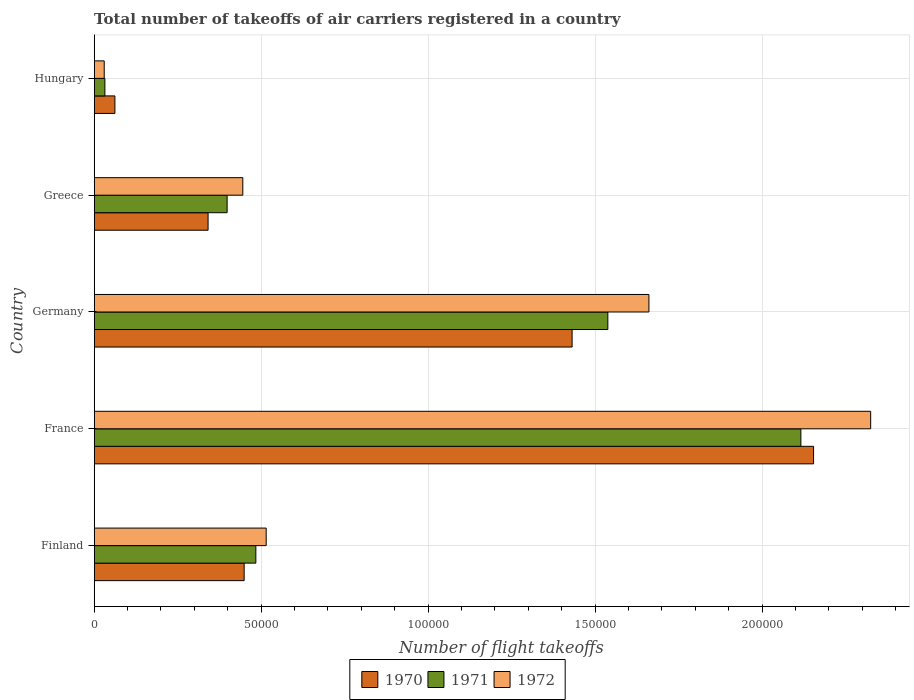How many groups of bars are there?
Keep it short and to the point. 5. Are the number of bars per tick equal to the number of legend labels?
Provide a succinct answer. Yes. How many bars are there on the 1st tick from the bottom?
Provide a succinct answer. 3. What is the label of the 4th group of bars from the top?
Offer a terse response. France. What is the total number of flight takeoffs in 1972 in Hungary?
Make the answer very short. 3000. Across all countries, what is the maximum total number of flight takeoffs in 1971?
Your answer should be very brief. 2.12e+05. Across all countries, what is the minimum total number of flight takeoffs in 1970?
Offer a terse response. 6200. In which country was the total number of flight takeoffs in 1970 maximum?
Give a very brief answer. France. In which country was the total number of flight takeoffs in 1970 minimum?
Your response must be concise. Hungary. What is the total total number of flight takeoffs in 1971 in the graph?
Make the answer very short. 4.57e+05. What is the difference between the total number of flight takeoffs in 1971 in Germany and that in Hungary?
Provide a succinct answer. 1.51e+05. What is the difference between the total number of flight takeoffs in 1972 in France and the total number of flight takeoffs in 1970 in Hungary?
Offer a terse response. 2.26e+05. What is the average total number of flight takeoffs in 1971 per country?
Ensure brevity in your answer.  9.14e+04. What is the difference between the total number of flight takeoffs in 1972 and total number of flight takeoffs in 1970 in Finland?
Ensure brevity in your answer.  6600. In how many countries, is the total number of flight takeoffs in 1972 greater than 60000 ?
Offer a very short reply. 2. What is the ratio of the total number of flight takeoffs in 1971 in France to that in Hungary?
Your answer should be very brief. 66.12. Is the difference between the total number of flight takeoffs in 1972 in Germany and Hungary greater than the difference between the total number of flight takeoffs in 1970 in Germany and Hungary?
Your answer should be very brief. Yes. What is the difference between the highest and the second highest total number of flight takeoffs in 1972?
Keep it short and to the point. 6.64e+04. What is the difference between the highest and the lowest total number of flight takeoffs in 1970?
Offer a very short reply. 2.09e+05. What does the 3rd bar from the top in Greece represents?
Make the answer very short. 1970. How many bars are there?
Make the answer very short. 15. Are all the bars in the graph horizontal?
Offer a terse response. Yes. What is the difference between two consecutive major ticks on the X-axis?
Make the answer very short. 5.00e+04. Does the graph contain any zero values?
Provide a succinct answer. No. Where does the legend appear in the graph?
Offer a terse response. Bottom center. How many legend labels are there?
Provide a succinct answer. 3. How are the legend labels stacked?
Your answer should be very brief. Horizontal. What is the title of the graph?
Provide a succinct answer. Total number of takeoffs of air carriers registered in a country. Does "2009" appear as one of the legend labels in the graph?
Your answer should be compact. No. What is the label or title of the X-axis?
Provide a short and direct response. Number of flight takeoffs. What is the Number of flight takeoffs in 1970 in Finland?
Your answer should be compact. 4.49e+04. What is the Number of flight takeoffs of 1971 in Finland?
Your answer should be very brief. 4.84e+04. What is the Number of flight takeoffs in 1972 in Finland?
Offer a very short reply. 5.15e+04. What is the Number of flight takeoffs of 1970 in France?
Offer a very short reply. 2.15e+05. What is the Number of flight takeoffs of 1971 in France?
Provide a short and direct response. 2.12e+05. What is the Number of flight takeoffs in 1972 in France?
Provide a succinct answer. 2.32e+05. What is the Number of flight takeoffs of 1970 in Germany?
Provide a succinct answer. 1.43e+05. What is the Number of flight takeoffs in 1971 in Germany?
Your answer should be very brief. 1.54e+05. What is the Number of flight takeoffs in 1972 in Germany?
Offer a very short reply. 1.66e+05. What is the Number of flight takeoffs of 1970 in Greece?
Keep it short and to the point. 3.41e+04. What is the Number of flight takeoffs of 1971 in Greece?
Give a very brief answer. 3.98e+04. What is the Number of flight takeoffs of 1972 in Greece?
Make the answer very short. 4.45e+04. What is the Number of flight takeoffs of 1970 in Hungary?
Ensure brevity in your answer.  6200. What is the Number of flight takeoffs in 1971 in Hungary?
Provide a succinct answer. 3200. What is the Number of flight takeoffs in 1972 in Hungary?
Provide a short and direct response. 3000. Across all countries, what is the maximum Number of flight takeoffs in 1970?
Give a very brief answer. 2.15e+05. Across all countries, what is the maximum Number of flight takeoffs in 1971?
Provide a succinct answer. 2.12e+05. Across all countries, what is the maximum Number of flight takeoffs of 1972?
Provide a short and direct response. 2.32e+05. Across all countries, what is the minimum Number of flight takeoffs of 1970?
Make the answer very short. 6200. Across all countries, what is the minimum Number of flight takeoffs of 1971?
Offer a terse response. 3200. Across all countries, what is the minimum Number of flight takeoffs in 1972?
Offer a terse response. 3000. What is the total Number of flight takeoffs of 1970 in the graph?
Make the answer very short. 4.44e+05. What is the total Number of flight takeoffs in 1971 in the graph?
Your answer should be very brief. 4.57e+05. What is the total Number of flight takeoffs in 1972 in the graph?
Your answer should be very brief. 4.98e+05. What is the difference between the Number of flight takeoffs of 1970 in Finland and that in France?
Offer a terse response. -1.70e+05. What is the difference between the Number of flight takeoffs in 1971 in Finland and that in France?
Give a very brief answer. -1.63e+05. What is the difference between the Number of flight takeoffs in 1972 in Finland and that in France?
Keep it short and to the point. -1.81e+05. What is the difference between the Number of flight takeoffs in 1970 in Finland and that in Germany?
Ensure brevity in your answer.  -9.82e+04. What is the difference between the Number of flight takeoffs in 1971 in Finland and that in Germany?
Your response must be concise. -1.05e+05. What is the difference between the Number of flight takeoffs of 1972 in Finland and that in Germany?
Keep it short and to the point. -1.15e+05. What is the difference between the Number of flight takeoffs in 1970 in Finland and that in Greece?
Provide a succinct answer. 1.08e+04. What is the difference between the Number of flight takeoffs in 1971 in Finland and that in Greece?
Provide a short and direct response. 8600. What is the difference between the Number of flight takeoffs of 1972 in Finland and that in Greece?
Keep it short and to the point. 7000. What is the difference between the Number of flight takeoffs in 1970 in Finland and that in Hungary?
Offer a terse response. 3.87e+04. What is the difference between the Number of flight takeoffs of 1971 in Finland and that in Hungary?
Provide a succinct answer. 4.52e+04. What is the difference between the Number of flight takeoffs in 1972 in Finland and that in Hungary?
Your answer should be very brief. 4.85e+04. What is the difference between the Number of flight takeoffs in 1970 in France and that in Germany?
Offer a terse response. 7.23e+04. What is the difference between the Number of flight takeoffs in 1971 in France and that in Germany?
Offer a terse response. 5.78e+04. What is the difference between the Number of flight takeoffs of 1972 in France and that in Germany?
Give a very brief answer. 6.64e+04. What is the difference between the Number of flight takeoffs of 1970 in France and that in Greece?
Your answer should be very brief. 1.81e+05. What is the difference between the Number of flight takeoffs in 1971 in France and that in Greece?
Your answer should be very brief. 1.72e+05. What is the difference between the Number of flight takeoffs of 1972 in France and that in Greece?
Provide a short and direct response. 1.88e+05. What is the difference between the Number of flight takeoffs in 1970 in France and that in Hungary?
Your response must be concise. 2.09e+05. What is the difference between the Number of flight takeoffs of 1971 in France and that in Hungary?
Make the answer very short. 2.08e+05. What is the difference between the Number of flight takeoffs of 1972 in France and that in Hungary?
Your answer should be very brief. 2.30e+05. What is the difference between the Number of flight takeoffs of 1970 in Germany and that in Greece?
Make the answer very short. 1.09e+05. What is the difference between the Number of flight takeoffs in 1971 in Germany and that in Greece?
Keep it short and to the point. 1.14e+05. What is the difference between the Number of flight takeoffs in 1972 in Germany and that in Greece?
Offer a terse response. 1.22e+05. What is the difference between the Number of flight takeoffs in 1970 in Germany and that in Hungary?
Offer a very short reply. 1.37e+05. What is the difference between the Number of flight takeoffs of 1971 in Germany and that in Hungary?
Provide a succinct answer. 1.51e+05. What is the difference between the Number of flight takeoffs of 1972 in Germany and that in Hungary?
Keep it short and to the point. 1.63e+05. What is the difference between the Number of flight takeoffs of 1970 in Greece and that in Hungary?
Ensure brevity in your answer.  2.79e+04. What is the difference between the Number of flight takeoffs in 1971 in Greece and that in Hungary?
Your answer should be very brief. 3.66e+04. What is the difference between the Number of flight takeoffs of 1972 in Greece and that in Hungary?
Your answer should be very brief. 4.15e+04. What is the difference between the Number of flight takeoffs of 1970 in Finland and the Number of flight takeoffs of 1971 in France?
Your answer should be very brief. -1.67e+05. What is the difference between the Number of flight takeoffs in 1970 in Finland and the Number of flight takeoffs in 1972 in France?
Ensure brevity in your answer.  -1.88e+05. What is the difference between the Number of flight takeoffs of 1971 in Finland and the Number of flight takeoffs of 1972 in France?
Make the answer very short. -1.84e+05. What is the difference between the Number of flight takeoffs of 1970 in Finland and the Number of flight takeoffs of 1971 in Germany?
Provide a succinct answer. -1.09e+05. What is the difference between the Number of flight takeoffs in 1970 in Finland and the Number of flight takeoffs in 1972 in Germany?
Keep it short and to the point. -1.21e+05. What is the difference between the Number of flight takeoffs of 1971 in Finland and the Number of flight takeoffs of 1972 in Germany?
Make the answer very short. -1.18e+05. What is the difference between the Number of flight takeoffs in 1970 in Finland and the Number of flight takeoffs in 1971 in Greece?
Make the answer very short. 5100. What is the difference between the Number of flight takeoffs of 1970 in Finland and the Number of flight takeoffs of 1972 in Greece?
Ensure brevity in your answer.  400. What is the difference between the Number of flight takeoffs of 1971 in Finland and the Number of flight takeoffs of 1972 in Greece?
Provide a succinct answer. 3900. What is the difference between the Number of flight takeoffs of 1970 in Finland and the Number of flight takeoffs of 1971 in Hungary?
Your answer should be very brief. 4.17e+04. What is the difference between the Number of flight takeoffs in 1970 in Finland and the Number of flight takeoffs in 1972 in Hungary?
Make the answer very short. 4.19e+04. What is the difference between the Number of flight takeoffs of 1971 in Finland and the Number of flight takeoffs of 1972 in Hungary?
Give a very brief answer. 4.54e+04. What is the difference between the Number of flight takeoffs of 1970 in France and the Number of flight takeoffs of 1971 in Germany?
Provide a short and direct response. 6.16e+04. What is the difference between the Number of flight takeoffs of 1970 in France and the Number of flight takeoffs of 1972 in Germany?
Offer a terse response. 4.93e+04. What is the difference between the Number of flight takeoffs of 1971 in France and the Number of flight takeoffs of 1972 in Germany?
Your answer should be compact. 4.55e+04. What is the difference between the Number of flight takeoffs in 1970 in France and the Number of flight takeoffs in 1971 in Greece?
Make the answer very short. 1.76e+05. What is the difference between the Number of flight takeoffs in 1970 in France and the Number of flight takeoffs in 1972 in Greece?
Your response must be concise. 1.71e+05. What is the difference between the Number of flight takeoffs in 1971 in France and the Number of flight takeoffs in 1972 in Greece?
Provide a succinct answer. 1.67e+05. What is the difference between the Number of flight takeoffs in 1970 in France and the Number of flight takeoffs in 1971 in Hungary?
Provide a succinct answer. 2.12e+05. What is the difference between the Number of flight takeoffs in 1970 in France and the Number of flight takeoffs in 1972 in Hungary?
Provide a short and direct response. 2.12e+05. What is the difference between the Number of flight takeoffs of 1971 in France and the Number of flight takeoffs of 1972 in Hungary?
Offer a terse response. 2.09e+05. What is the difference between the Number of flight takeoffs of 1970 in Germany and the Number of flight takeoffs of 1971 in Greece?
Keep it short and to the point. 1.03e+05. What is the difference between the Number of flight takeoffs of 1970 in Germany and the Number of flight takeoffs of 1972 in Greece?
Your answer should be compact. 9.86e+04. What is the difference between the Number of flight takeoffs of 1971 in Germany and the Number of flight takeoffs of 1972 in Greece?
Ensure brevity in your answer.  1.09e+05. What is the difference between the Number of flight takeoffs of 1970 in Germany and the Number of flight takeoffs of 1971 in Hungary?
Your answer should be very brief. 1.40e+05. What is the difference between the Number of flight takeoffs in 1970 in Germany and the Number of flight takeoffs in 1972 in Hungary?
Your answer should be compact. 1.40e+05. What is the difference between the Number of flight takeoffs of 1971 in Germany and the Number of flight takeoffs of 1972 in Hungary?
Offer a very short reply. 1.51e+05. What is the difference between the Number of flight takeoffs of 1970 in Greece and the Number of flight takeoffs of 1971 in Hungary?
Make the answer very short. 3.09e+04. What is the difference between the Number of flight takeoffs in 1970 in Greece and the Number of flight takeoffs in 1972 in Hungary?
Your response must be concise. 3.11e+04. What is the difference between the Number of flight takeoffs of 1971 in Greece and the Number of flight takeoffs of 1972 in Hungary?
Provide a succinct answer. 3.68e+04. What is the average Number of flight takeoffs in 1970 per country?
Offer a very short reply. 8.87e+04. What is the average Number of flight takeoffs of 1971 per country?
Give a very brief answer. 9.14e+04. What is the average Number of flight takeoffs in 1972 per country?
Provide a succinct answer. 9.95e+04. What is the difference between the Number of flight takeoffs of 1970 and Number of flight takeoffs of 1971 in Finland?
Your response must be concise. -3500. What is the difference between the Number of flight takeoffs of 1970 and Number of flight takeoffs of 1972 in Finland?
Ensure brevity in your answer.  -6600. What is the difference between the Number of flight takeoffs of 1971 and Number of flight takeoffs of 1972 in Finland?
Your response must be concise. -3100. What is the difference between the Number of flight takeoffs of 1970 and Number of flight takeoffs of 1971 in France?
Ensure brevity in your answer.  3800. What is the difference between the Number of flight takeoffs in 1970 and Number of flight takeoffs in 1972 in France?
Keep it short and to the point. -1.71e+04. What is the difference between the Number of flight takeoffs of 1971 and Number of flight takeoffs of 1972 in France?
Offer a very short reply. -2.09e+04. What is the difference between the Number of flight takeoffs of 1970 and Number of flight takeoffs of 1971 in Germany?
Offer a terse response. -1.07e+04. What is the difference between the Number of flight takeoffs in 1970 and Number of flight takeoffs in 1972 in Germany?
Your answer should be compact. -2.30e+04. What is the difference between the Number of flight takeoffs in 1971 and Number of flight takeoffs in 1972 in Germany?
Your answer should be compact. -1.23e+04. What is the difference between the Number of flight takeoffs in 1970 and Number of flight takeoffs in 1971 in Greece?
Make the answer very short. -5700. What is the difference between the Number of flight takeoffs of 1970 and Number of flight takeoffs of 1972 in Greece?
Offer a very short reply. -1.04e+04. What is the difference between the Number of flight takeoffs in 1971 and Number of flight takeoffs in 1972 in Greece?
Keep it short and to the point. -4700. What is the difference between the Number of flight takeoffs in 1970 and Number of flight takeoffs in 1971 in Hungary?
Give a very brief answer. 3000. What is the difference between the Number of flight takeoffs in 1970 and Number of flight takeoffs in 1972 in Hungary?
Make the answer very short. 3200. What is the difference between the Number of flight takeoffs of 1971 and Number of flight takeoffs of 1972 in Hungary?
Your answer should be compact. 200. What is the ratio of the Number of flight takeoffs of 1970 in Finland to that in France?
Provide a succinct answer. 0.21. What is the ratio of the Number of flight takeoffs of 1971 in Finland to that in France?
Make the answer very short. 0.23. What is the ratio of the Number of flight takeoffs in 1972 in Finland to that in France?
Give a very brief answer. 0.22. What is the ratio of the Number of flight takeoffs of 1970 in Finland to that in Germany?
Ensure brevity in your answer.  0.31. What is the ratio of the Number of flight takeoffs of 1971 in Finland to that in Germany?
Your answer should be compact. 0.31. What is the ratio of the Number of flight takeoffs of 1972 in Finland to that in Germany?
Make the answer very short. 0.31. What is the ratio of the Number of flight takeoffs of 1970 in Finland to that in Greece?
Offer a very short reply. 1.32. What is the ratio of the Number of flight takeoffs in 1971 in Finland to that in Greece?
Offer a terse response. 1.22. What is the ratio of the Number of flight takeoffs in 1972 in Finland to that in Greece?
Keep it short and to the point. 1.16. What is the ratio of the Number of flight takeoffs of 1970 in Finland to that in Hungary?
Give a very brief answer. 7.24. What is the ratio of the Number of flight takeoffs of 1971 in Finland to that in Hungary?
Give a very brief answer. 15.12. What is the ratio of the Number of flight takeoffs of 1972 in Finland to that in Hungary?
Offer a terse response. 17.17. What is the ratio of the Number of flight takeoffs of 1970 in France to that in Germany?
Your answer should be very brief. 1.51. What is the ratio of the Number of flight takeoffs in 1971 in France to that in Germany?
Your answer should be compact. 1.38. What is the ratio of the Number of flight takeoffs of 1972 in France to that in Germany?
Keep it short and to the point. 1.4. What is the ratio of the Number of flight takeoffs of 1970 in France to that in Greece?
Keep it short and to the point. 6.32. What is the ratio of the Number of flight takeoffs in 1971 in France to that in Greece?
Ensure brevity in your answer.  5.32. What is the ratio of the Number of flight takeoffs of 1972 in France to that in Greece?
Your answer should be very brief. 5.22. What is the ratio of the Number of flight takeoffs in 1970 in France to that in Hungary?
Ensure brevity in your answer.  34.74. What is the ratio of the Number of flight takeoffs in 1971 in France to that in Hungary?
Provide a succinct answer. 66.12. What is the ratio of the Number of flight takeoffs in 1972 in France to that in Hungary?
Ensure brevity in your answer.  77.5. What is the ratio of the Number of flight takeoffs of 1970 in Germany to that in Greece?
Your answer should be compact. 4.2. What is the ratio of the Number of flight takeoffs in 1971 in Germany to that in Greece?
Offer a terse response. 3.86. What is the ratio of the Number of flight takeoffs of 1972 in Germany to that in Greece?
Provide a short and direct response. 3.73. What is the ratio of the Number of flight takeoffs of 1970 in Germany to that in Hungary?
Offer a terse response. 23.08. What is the ratio of the Number of flight takeoffs in 1971 in Germany to that in Hungary?
Offer a terse response. 48.06. What is the ratio of the Number of flight takeoffs in 1972 in Germany to that in Hungary?
Provide a succinct answer. 55.37. What is the ratio of the Number of flight takeoffs of 1970 in Greece to that in Hungary?
Make the answer very short. 5.5. What is the ratio of the Number of flight takeoffs of 1971 in Greece to that in Hungary?
Give a very brief answer. 12.44. What is the ratio of the Number of flight takeoffs in 1972 in Greece to that in Hungary?
Offer a very short reply. 14.83. What is the difference between the highest and the second highest Number of flight takeoffs in 1970?
Your answer should be very brief. 7.23e+04. What is the difference between the highest and the second highest Number of flight takeoffs of 1971?
Your response must be concise. 5.78e+04. What is the difference between the highest and the second highest Number of flight takeoffs in 1972?
Provide a short and direct response. 6.64e+04. What is the difference between the highest and the lowest Number of flight takeoffs of 1970?
Give a very brief answer. 2.09e+05. What is the difference between the highest and the lowest Number of flight takeoffs in 1971?
Your answer should be very brief. 2.08e+05. What is the difference between the highest and the lowest Number of flight takeoffs in 1972?
Offer a very short reply. 2.30e+05. 